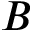<formula> <loc_0><loc_0><loc_500><loc_500>B</formula> 